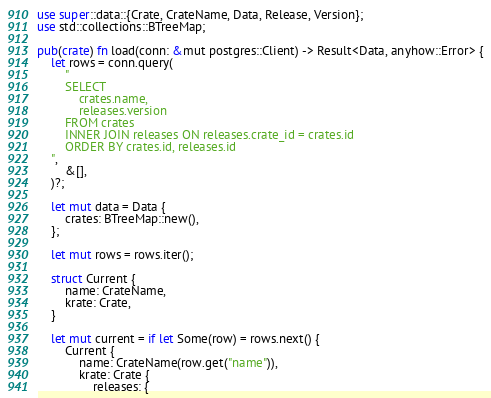Convert code to text. <code><loc_0><loc_0><loc_500><loc_500><_Rust_>use super::data::{Crate, CrateName, Data, Release, Version};
use std::collections::BTreeMap;

pub(crate) fn load(conn: &mut postgres::Client) -> Result<Data, anyhow::Error> {
    let rows = conn.query(
        "
        SELECT
            crates.name,
            releases.version
        FROM crates
        INNER JOIN releases ON releases.crate_id = crates.id
        ORDER BY crates.id, releases.id
    ",
        &[],
    )?;

    let mut data = Data {
        crates: BTreeMap::new(),
    };

    let mut rows = rows.iter();

    struct Current {
        name: CrateName,
        krate: Crate,
    }

    let mut current = if let Some(row) = rows.next() {
        Current {
            name: CrateName(row.get("name")),
            krate: Crate {
                releases: {</code> 